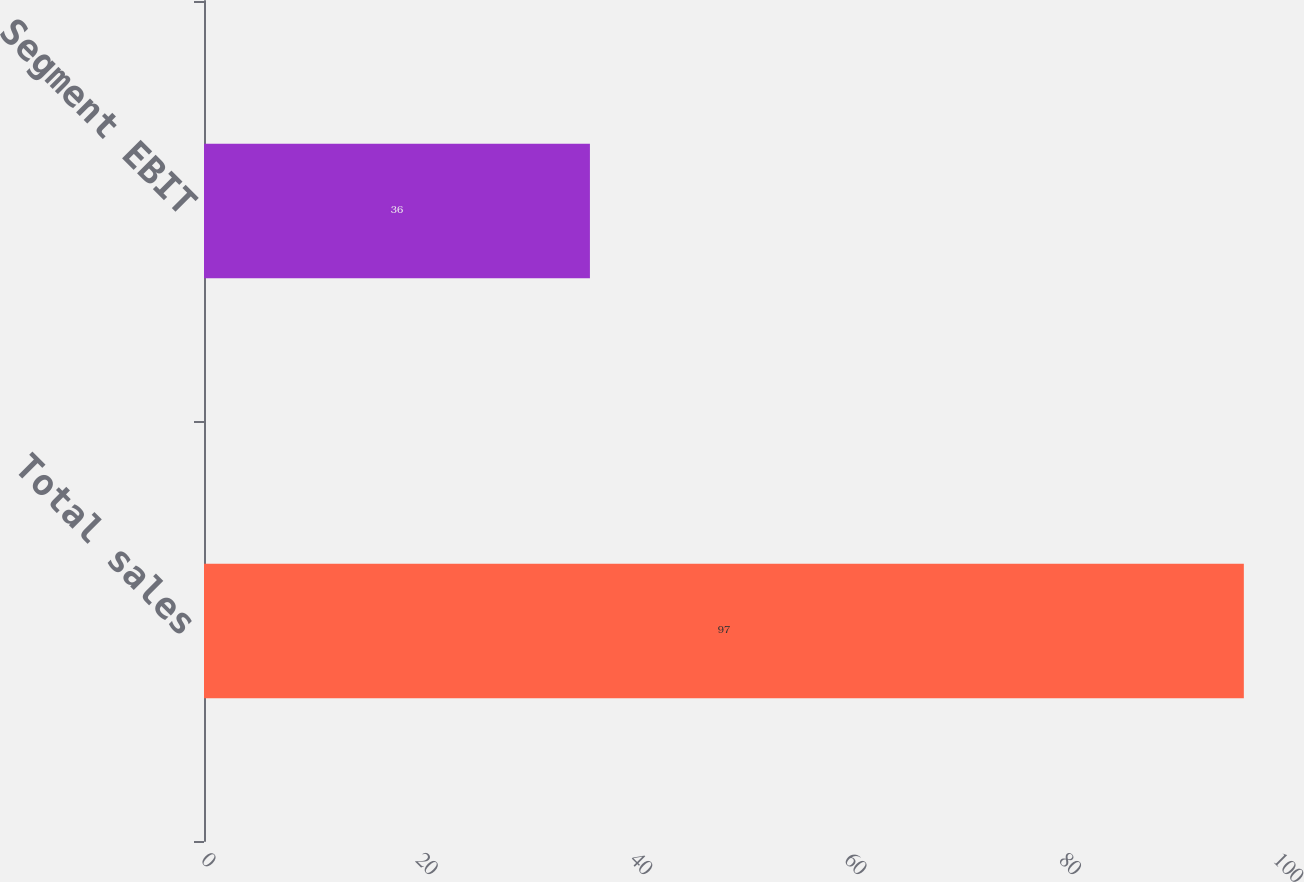Convert chart to OTSL. <chart><loc_0><loc_0><loc_500><loc_500><bar_chart><fcel>Total sales<fcel>Segment EBIT<nl><fcel>97<fcel>36<nl></chart> 